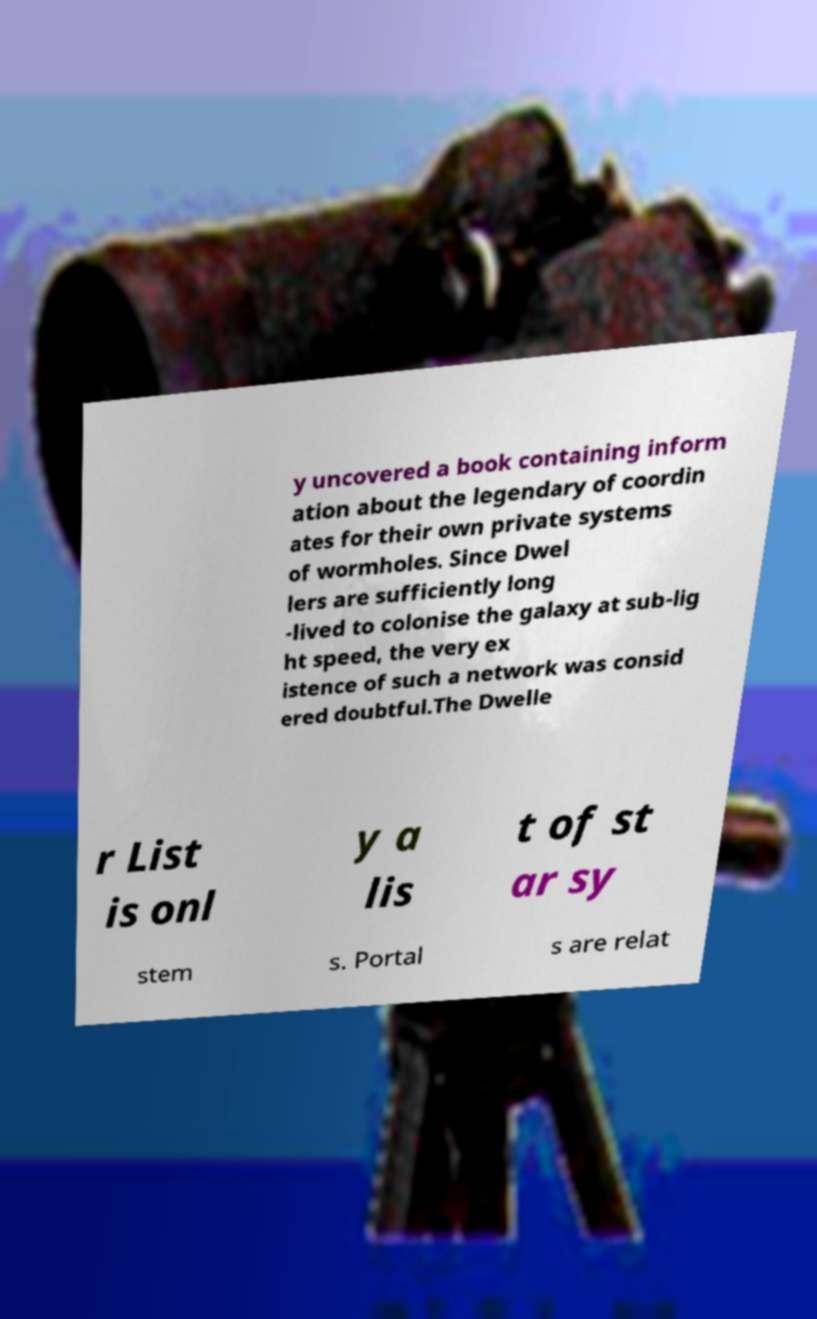I need the written content from this picture converted into text. Can you do that? y uncovered a book containing inform ation about the legendary of coordin ates for their own private systems of wormholes. Since Dwel lers are sufficiently long -lived to colonise the galaxy at sub-lig ht speed, the very ex istence of such a network was consid ered doubtful.The Dwelle r List is onl y a lis t of st ar sy stem s. Portal s are relat 